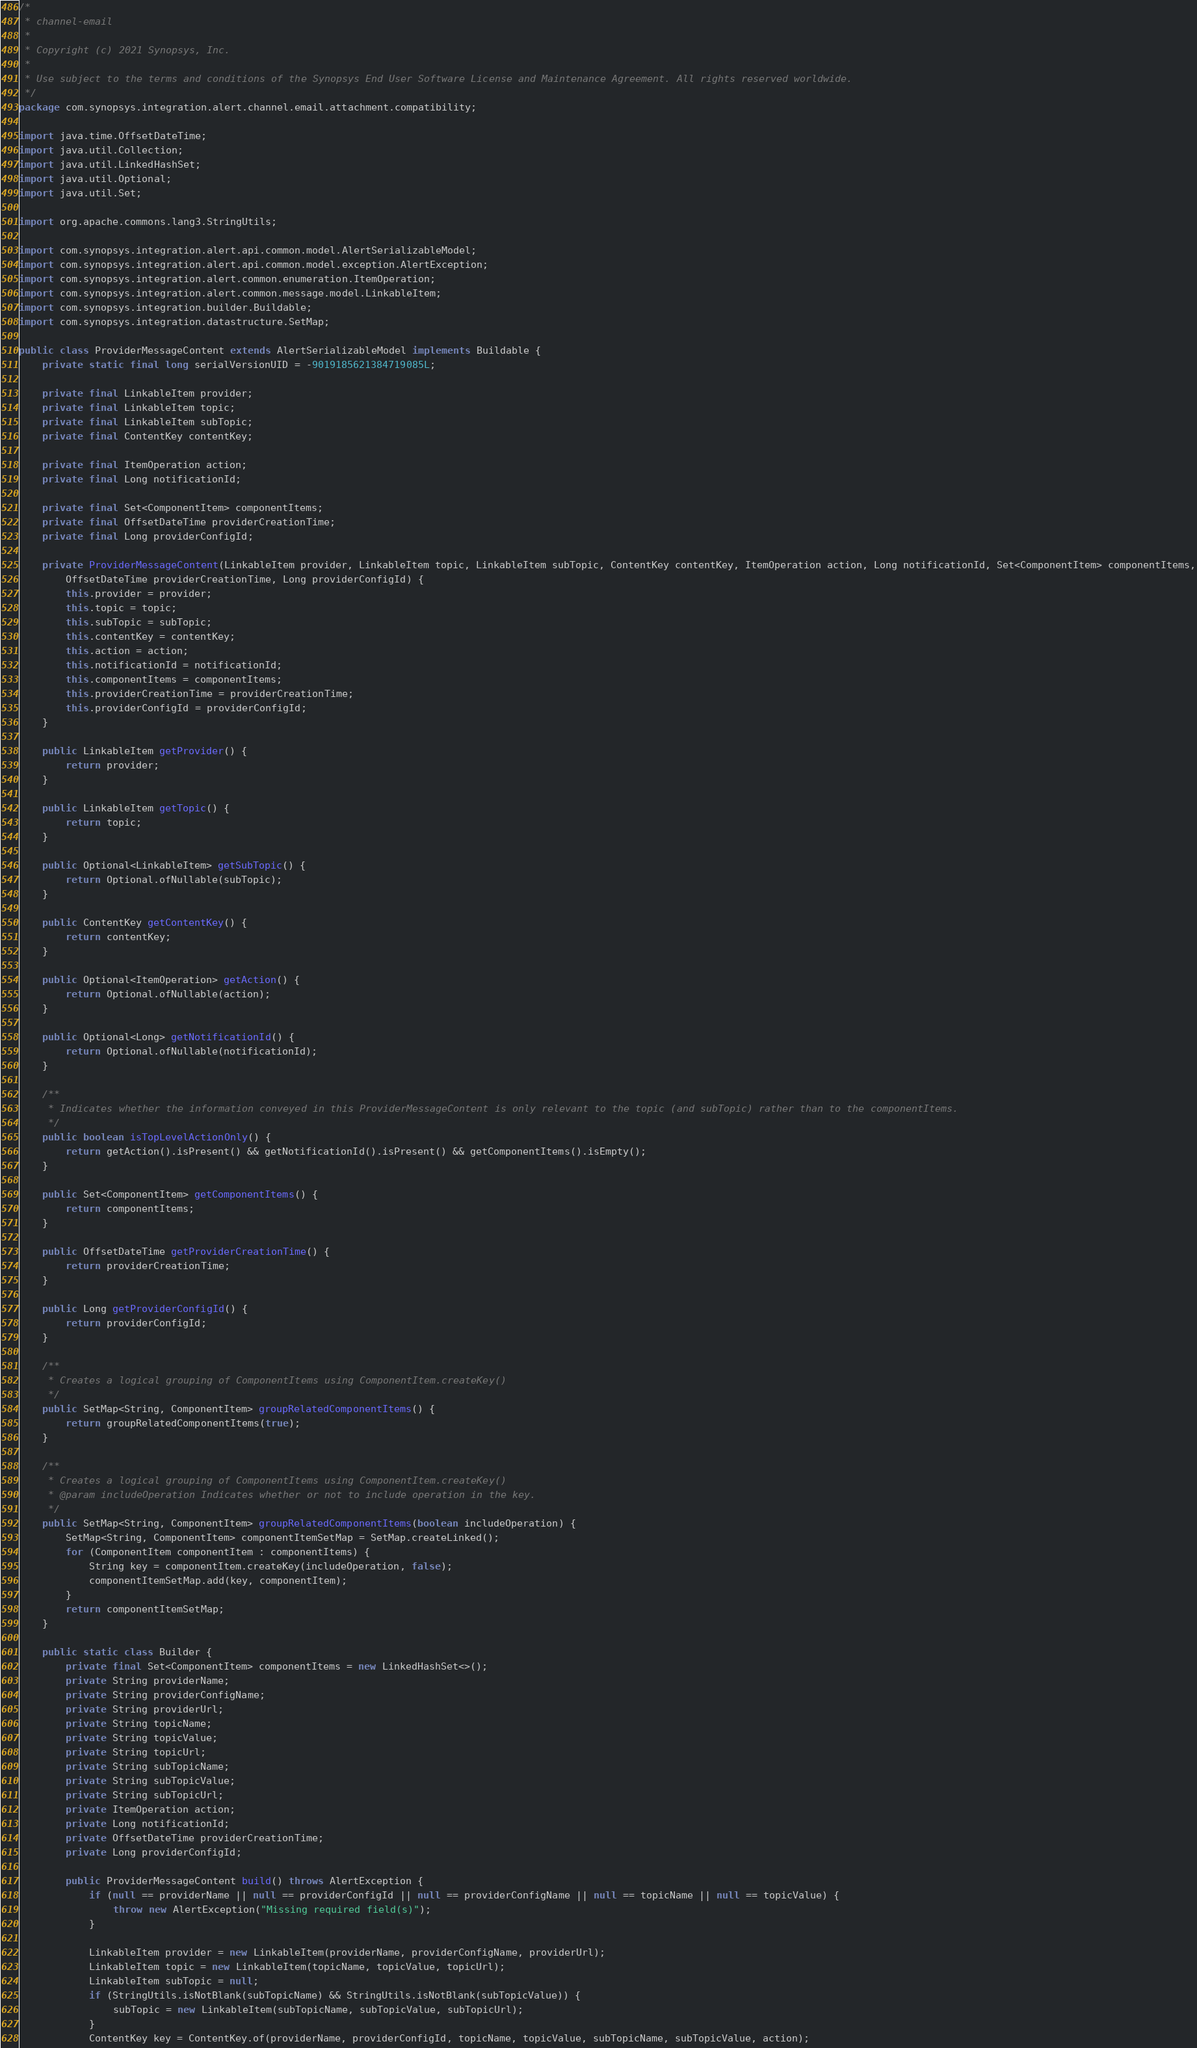Convert code to text. <code><loc_0><loc_0><loc_500><loc_500><_Java_>/*
 * channel-email
 *
 * Copyright (c) 2021 Synopsys, Inc.
 *
 * Use subject to the terms and conditions of the Synopsys End User Software License and Maintenance Agreement. All rights reserved worldwide.
 */
package com.synopsys.integration.alert.channel.email.attachment.compatibility;

import java.time.OffsetDateTime;
import java.util.Collection;
import java.util.LinkedHashSet;
import java.util.Optional;
import java.util.Set;

import org.apache.commons.lang3.StringUtils;

import com.synopsys.integration.alert.api.common.model.AlertSerializableModel;
import com.synopsys.integration.alert.api.common.model.exception.AlertException;
import com.synopsys.integration.alert.common.enumeration.ItemOperation;
import com.synopsys.integration.alert.common.message.model.LinkableItem;
import com.synopsys.integration.builder.Buildable;
import com.synopsys.integration.datastructure.SetMap;

public class ProviderMessageContent extends AlertSerializableModel implements Buildable {
    private static final long serialVersionUID = -9019185621384719085L;

    private final LinkableItem provider;
    private final LinkableItem topic;
    private final LinkableItem subTopic;
    private final ContentKey contentKey;

    private final ItemOperation action;
    private final Long notificationId;

    private final Set<ComponentItem> componentItems;
    private final OffsetDateTime providerCreationTime;
    private final Long providerConfigId;

    private ProviderMessageContent(LinkableItem provider, LinkableItem topic, LinkableItem subTopic, ContentKey contentKey, ItemOperation action, Long notificationId, Set<ComponentItem> componentItems,
        OffsetDateTime providerCreationTime, Long providerConfigId) {
        this.provider = provider;
        this.topic = topic;
        this.subTopic = subTopic;
        this.contentKey = contentKey;
        this.action = action;
        this.notificationId = notificationId;
        this.componentItems = componentItems;
        this.providerCreationTime = providerCreationTime;
        this.providerConfigId = providerConfigId;
    }

    public LinkableItem getProvider() {
        return provider;
    }

    public LinkableItem getTopic() {
        return topic;
    }

    public Optional<LinkableItem> getSubTopic() {
        return Optional.ofNullable(subTopic);
    }

    public ContentKey getContentKey() {
        return contentKey;
    }

    public Optional<ItemOperation> getAction() {
        return Optional.ofNullable(action);
    }

    public Optional<Long> getNotificationId() {
        return Optional.ofNullable(notificationId);
    }

    /**
     * Indicates whether the information conveyed in this ProviderMessageContent is only relevant to the topic (and subTopic) rather than to the componentItems.
     */
    public boolean isTopLevelActionOnly() {
        return getAction().isPresent() && getNotificationId().isPresent() && getComponentItems().isEmpty();
    }

    public Set<ComponentItem> getComponentItems() {
        return componentItems;
    }

    public OffsetDateTime getProviderCreationTime() {
        return providerCreationTime;
    }

    public Long getProviderConfigId() {
        return providerConfigId;
    }

    /**
     * Creates a logical grouping of ComponentItems using ComponentItem.createKey()
     */
    public SetMap<String, ComponentItem> groupRelatedComponentItems() {
        return groupRelatedComponentItems(true);
    }

    /**
     * Creates a logical grouping of ComponentItems using ComponentItem.createKey()
     * @param includeOperation Indicates whether or not to include operation in the key.
     */
    public SetMap<String, ComponentItem> groupRelatedComponentItems(boolean includeOperation) {
        SetMap<String, ComponentItem> componentItemSetMap = SetMap.createLinked();
        for (ComponentItem componentItem : componentItems) {
            String key = componentItem.createKey(includeOperation, false);
            componentItemSetMap.add(key, componentItem);
        }
        return componentItemSetMap;
    }

    public static class Builder {
        private final Set<ComponentItem> componentItems = new LinkedHashSet<>();
        private String providerName;
        private String providerConfigName;
        private String providerUrl;
        private String topicName;
        private String topicValue;
        private String topicUrl;
        private String subTopicName;
        private String subTopicValue;
        private String subTopicUrl;
        private ItemOperation action;
        private Long notificationId;
        private OffsetDateTime providerCreationTime;
        private Long providerConfigId;

        public ProviderMessageContent build() throws AlertException {
            if (null == providerName || null == providerConfigId || null == providerConfigName || null == topicName || null == topicValue) {
                throw new AlertException("Missing required field(s)");
            }

            LinkableItem provider = new LinkableItem(providerName, providerConfigName, providerUrl);
            LinkableItem topic = new LinkableItem(topicName, topicValue, topicUrl);
            LinkableItem subTopic = null;
            if (StringUtils.isNotBlank(subTopicName) && StringUtils.isNotBlank(subTopicValue)) {
                subTopic = new LinkableItem(subTopicName, subTopicValue, subTopicUrl);
            }
            ContentKey key = ContentKey.of(providerName, providerConfigId, topicName, topicValue, subTopicName, subTopicValue, action);</code> 